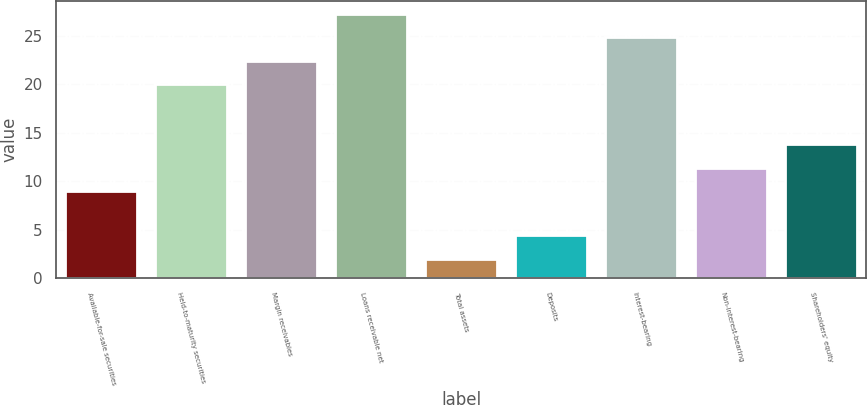Convert chart to OTSL. <chart><loc_0><loc_0><loc_500><loc_500><bar_chart><fcel>Available-for-sale securities<fcel>Held-to-maturity securities<fcel>Margin receivables<fcel>Loans receivable net<fcel>Total assets<fcel>Deposits<fcel>Interest-bearing<fcel>Non-interest-bearing<fcel>Shareholders' equity<nl><fcel>9<fcel>20<fcel>22.4<fcel>27.2<fcel>2<fcel>4.4<fcel>24.8<fcel>11.4<fcel>13.8<nl></chart> 